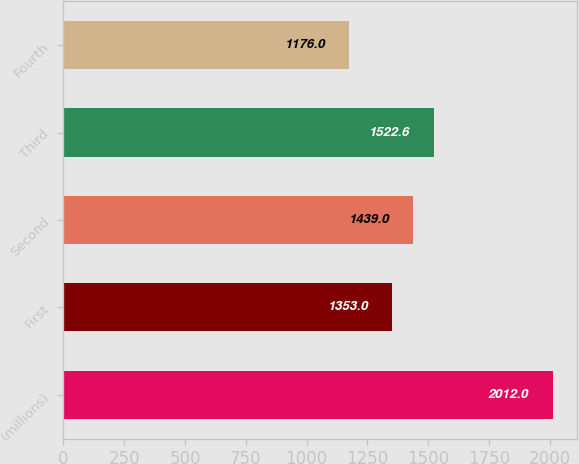Convert chart. <chart><loc_0><loc_0><loc_500><loc_500><bar_chart><fcel>(millions)<fcel>First<fcel>Second<fcel>Third<fcel>Fourth<nl><fcel>2012<fcel>1353<fcel>1439<fcel>1522.6<fcel>1176<nl></chart> 